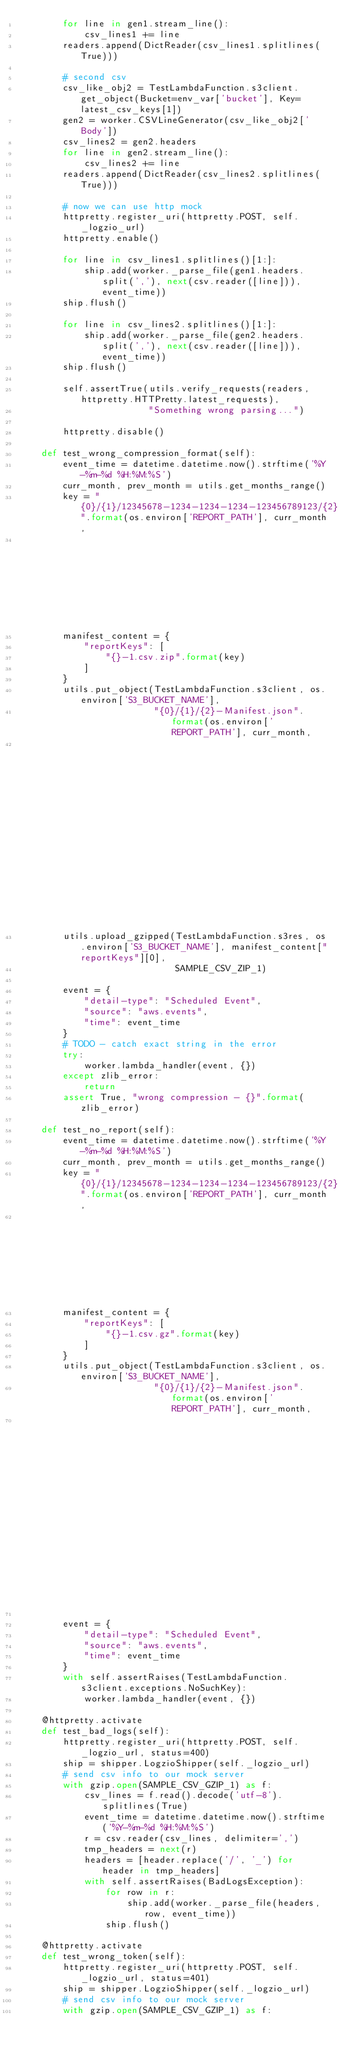<code> <loc_0><loc_0><loc_500><loc_500><_Python_>        for line in gen1.stream_line():
            csv_lines1 += line
        readers.append(DictReader(csv_lines1.splitlines(True)))

        # second csv
        csv_like_obj2 = TestLambdaFunction.s3client.get_object(Bucket=env_var['bucket'], Key=latest_csv_keys[1])
        gen2 = worker.CSVLineGenerator(csv_like_obj2['Body'])
        csv_lines2 = gen2.headers
        for line in gen2.stream_line():
            csv_lines2 += line
        readers.append(DictReader(csv_lines2.splitlines(True)))

        # now we can use http mock
        httpretty.register_uri(httpretty.POST, self._logzio_url)
        httpretty.enable()

        for line in csv_lines1.splitlines()[1:]:
            ship.add(worker._parse_file(gen1.headers.split(','), next(csv.reader([line])), event_time))
        ship.flush()

        for line in csv_lines2.splitlines()[1:]:
            ship.add(worker._parse_file(gen2.headers.split(','), next(csv.reader([line])), event_time))
        ship.flush()

        self.assertTrue(utils.verify_requests(readers, httpretty.HTTPretty.latest_requests),
                        "Something wrong parsing...")

        httpretty.disable()

    def test_wrong_compression_format(self):
        event_time = datetime.datetime.now().strftime('%Y-%m-%d %H:%M:%S')
        curr_month, prev_month = utils.get_months_range()
        key = "{0}/{1}/12345678-1234-1234-1234-123456789123/{2}".format(os.environ['REPORT_PATH'], curr_month,
                                                                        os.environ['REPORT_NAME'])
        manifest_content = {
            "reportKeys": [
                "{}-1.csv.zip".format(key)
            ]
        }
        utils.put_object(TestLambdaFunction.s3client, os.environ['S3_BUCKET_NAME'],
                         "{0}/{1}/{2}-Manifest.json".format(os.environ['REPORT_PATH'], curr_month,
                                                            os.environ['REPORT_NAME']), json.dumps(manifest_content))
        utils.upload_gzipped(TestLambdaFunction.s3res, os.environ['S3_BUCKET_NAME'], manifest_content["reportKeys"][0],
                             SAMPLE_CSV_ZIP_1)

        event = {
            "detail-type": "Scheduled Event",
            "source": "aws.events",
            "time": event_time
        }
        # TODO - catch exact string in the error
        try:
            worker.lambda_handler(event, {})
        except zlib_error:
            return
        assert True, "wrong compression - {}".format(zlib_error)

    def test_no_report(self):
        event_time = datetime.datetime.now().strftime('%Y-%m-%d %H:%M:%S')
        curr_month, prev_month = utils.get_months_range()
        key = "{0}/{1}/12345678-1234-1234-1234-123456789123/{2}".format(os.environ['REPORT_PATH'], curr_month,
                                                                        os.environ['REPORT_NAME'])
        manifest_content = {
            "reportKeys": [
                "{}-1.csv.gz".format(key)
            ]
        }
        utils.put_object(TestLambdaFunction.s3client, os.environ['S3_BUCKET_NAME'],
                         "{0}/{1}/{2}-Manifest.json".format(os.environ['REPORT_PATH'], curr_month,
                                                            os.environ['REPORT_NAME']), json.dumps(manifest_content))

        event = {
            "detail-type": "Scheduled Event",
            "source": "aws.events",
            "time": event_time
        }
        with self.assertRaises(TestLambdaFunction.s3client.exceptions.NoSuchKey):
            worker.lambda_handler(event, {})

    @httpretty.activate
    def test_bad_logs(self):
        httpretty.register_uri(httpretty.POST, self._logzio_url, status=400)
        ship = shipper.LogzioShipper(self._logzio_url)
        # send csv info to our mock server
        with gzip.open(SAMPLE_CSV_GZIP_1) as f:
            csv_lines = f.read().decode('utf-8').splitlines(True)
            event_time = datetime.datetime.now().strftime('%Y-%m-%d %H:%M:%S')
            r = csv.reader(csv_lines, delimiter=',')
            tmp_headers = next(r)
            headers = [header.replace('/', '_') for header in tmp_headers]
            with self.assertRaises(BadLogsException):
                for row in r:
                    ship.add(worker._parse_file(headers, row, event_time))
                ship.flush()

    @httpretty.activate
    def test_wrong_token(self):
        httpretty.register_uri(httpretty.POST, self._logzio_url, status=401)
        ship = shipper.LogzioShipper(self._logzio_url)
        # send csv info to our mock server
        with gzip.open(SAMPLE_CSV_GZIP_1) as f:</code> 